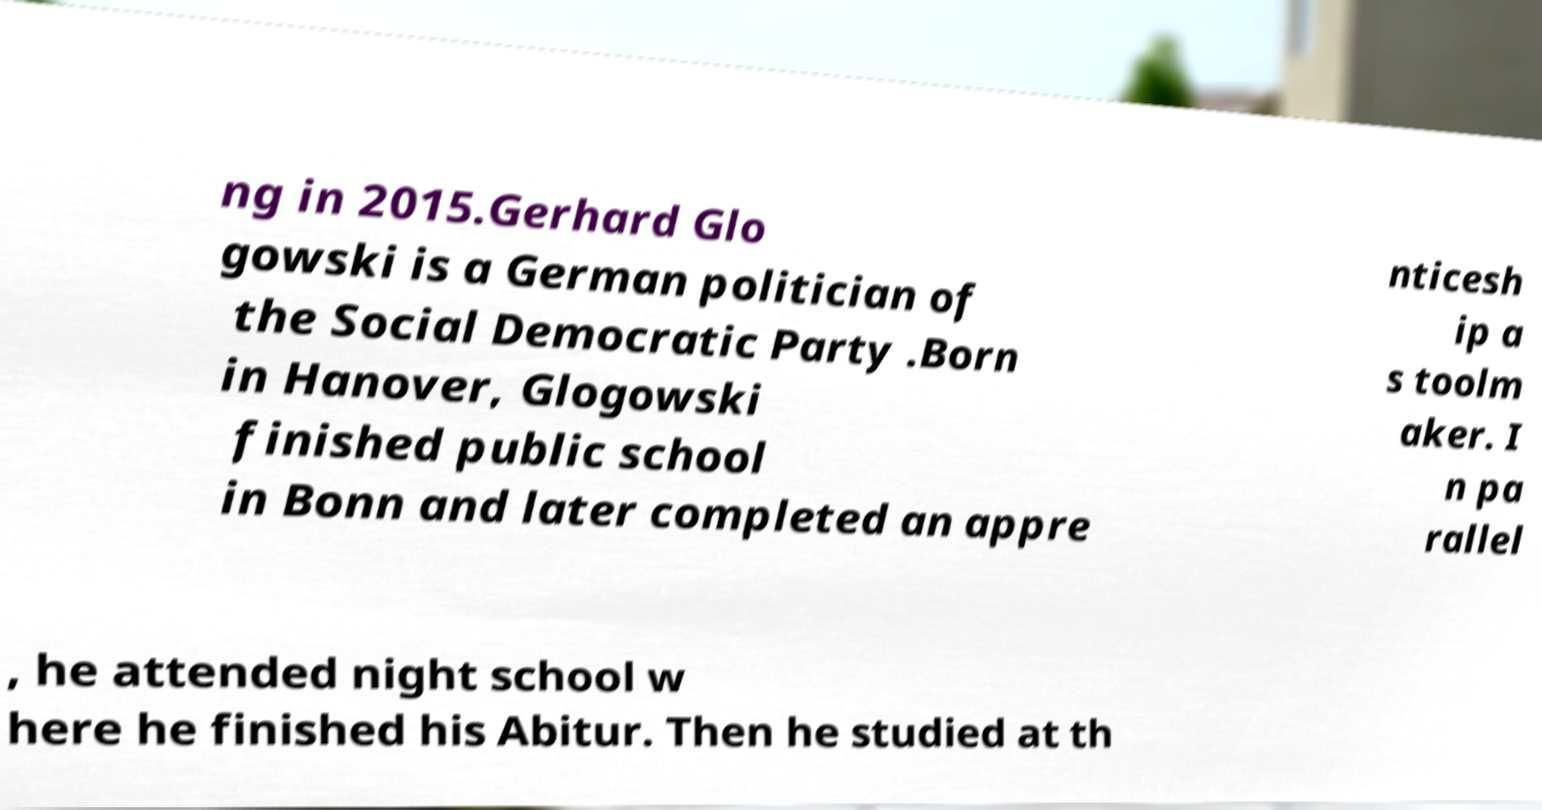Could you extract and type out the text from this image? ng in 2015.Gerhard Glo gowski is a German politician of the Social Democratic Party .Born in Hanover, Glogowski finished public school in Bonn and later completed an appre nticesh ip a s toolm aker. I n pa rallel , he attended night school w here he finished his Abitur. Then he studied at th 